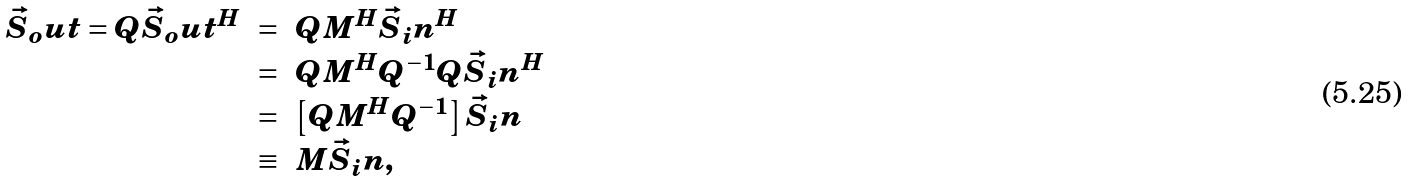<formula> <loc_0><loc_0><loc_500><loc_500>\begin{array} { r c l } \vec { S } _ { o } u t = Q \vec { S } _ { o } u t ^ { H } & = & Q M ^ { H } \vec { S } _ { i } n ^ { H } \\ & = & Q M ^ { H } Q ^ { - 1 } Q \vec { S } _ { i } n ^ { H } \\ & = & \left [ Q M ^ { H } Q ^ { - 1 } \right ] \vec { S } _ { i } n \\ & \equiv & M \vec { S } _ { i } n , \end{array}</formula> 